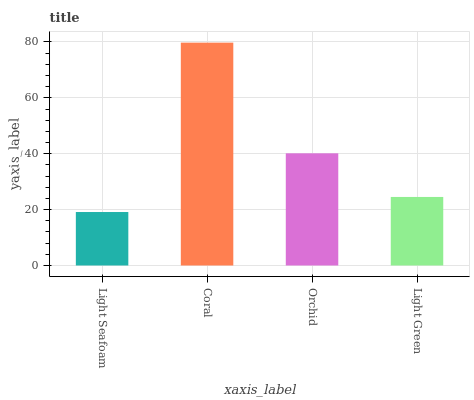Is Light Seafoam the minimum?
Answer yes or no. Yes. Is Coral the maximum?
Answer yes or no. Yes. Is Orchid the minimum?
Answer yes or no. No. Is Orchid the maximum?
Answer yes or no. No. Is Coral greater than Orchid?
Answer yes or no. Yes. Is Orchid less than Coral?
Answer yes or no. Yes. Is Orchid greater than Coral?
Answer yes or no. No. Is Coral less than Orchid?
Answer yes or no. No. Is Orchid the high median?
Answer yes or no. Yes. Is Light Green the low median?
Answer yes or no. Yes. Is Coral the high median?
Answer yes or no. No. Is Light Seafoam the low median?
Answer yes or no. No. 